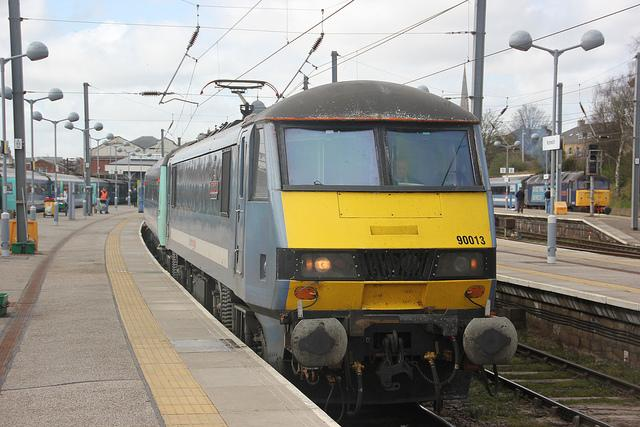For what group of people is the yellow area on the platform built?

Choices:
A) handicapped people
B) elderly people
C) blind people
D) pregnant women blind people 